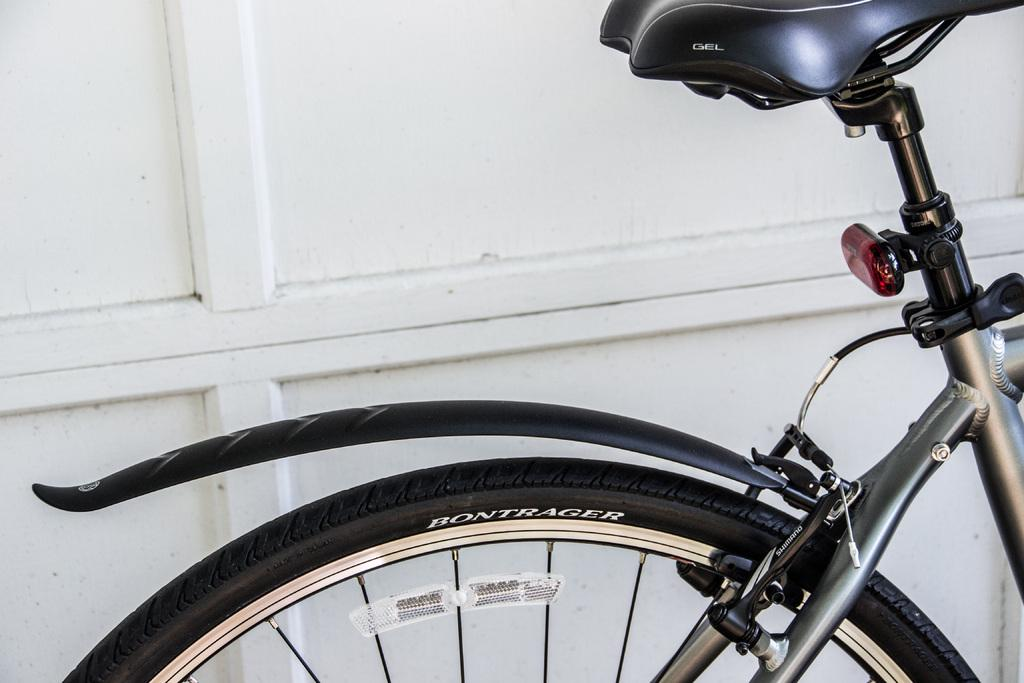What is the main subject of the image? The main subject of the image is a bicycle. What can be seen in the background of the image? There is a wall in the background of the image. What type of skirt is the clam wearing in the image? There is no clam or skirt present in the image; it features a bicycle and a wall in the background. 